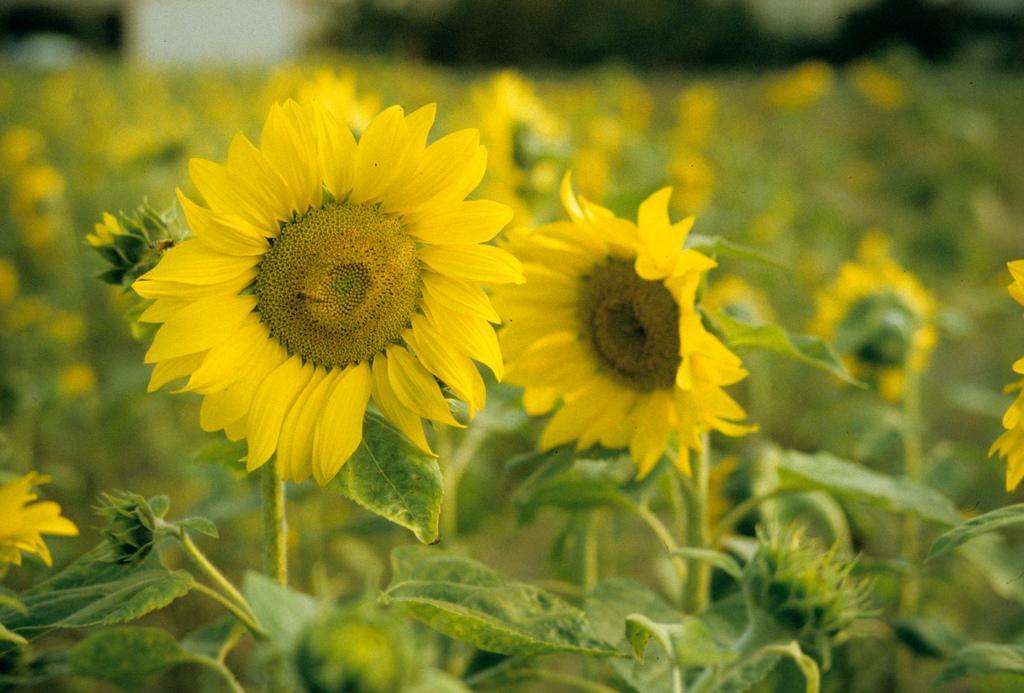Can you describe this image briefly? In the picture we can see many plants with flowers which are yellow in color with petals. 